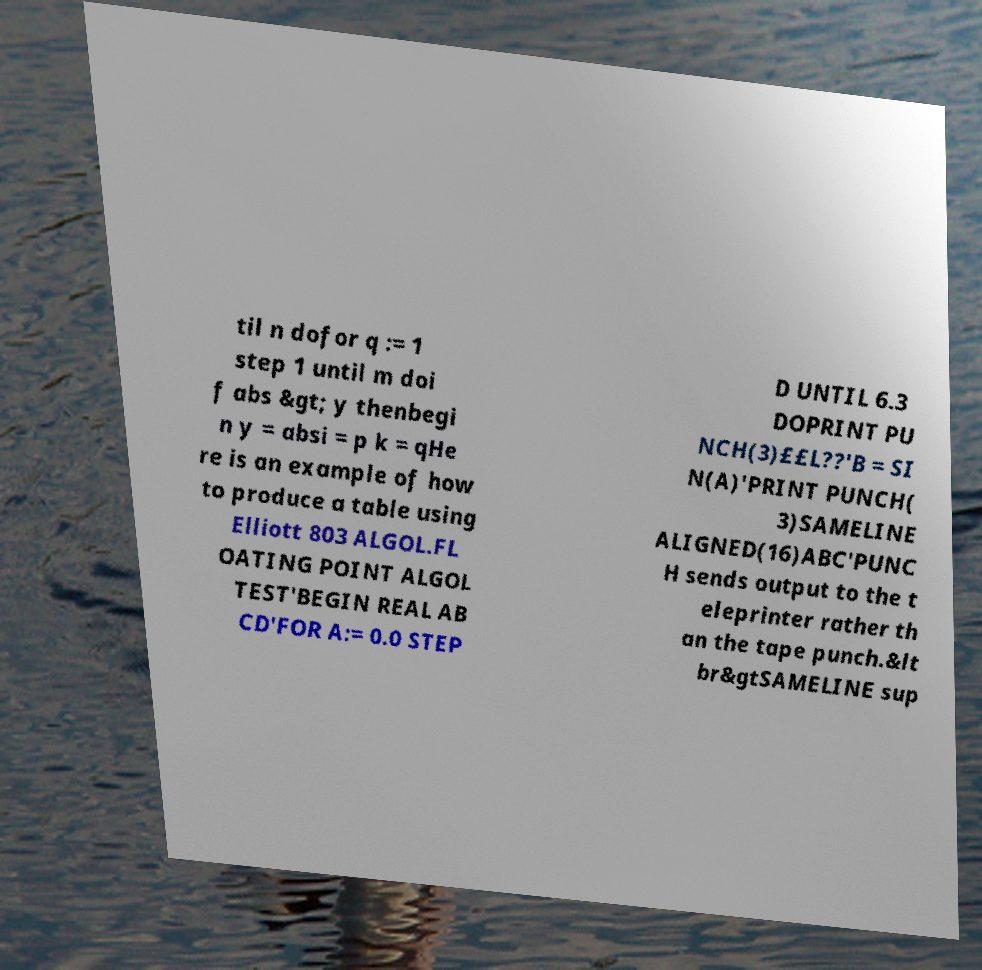Please identify and transcribe the text found in this image. til n dofor q := 1 step 1 until m doi f abs &gt; y thenbegi n y = absi = p k = qHe re is an example of how to produce a table using Elliott 803 ALGOL.FL OATING POINT ALGOL TEST'BEGIN REAL AB CD'FOR A:= 0.0 STEP D UNTIL 6.3 DOPRINT PU NCH(3)££L??'B = SI N(A)'PRINT PUNCH( 3)SAMELINE ALIGNED(16)ABC'PUNC H sends output to the t eleprinter rather th an the tape punch.&lt br&gtSAMELINE sup 